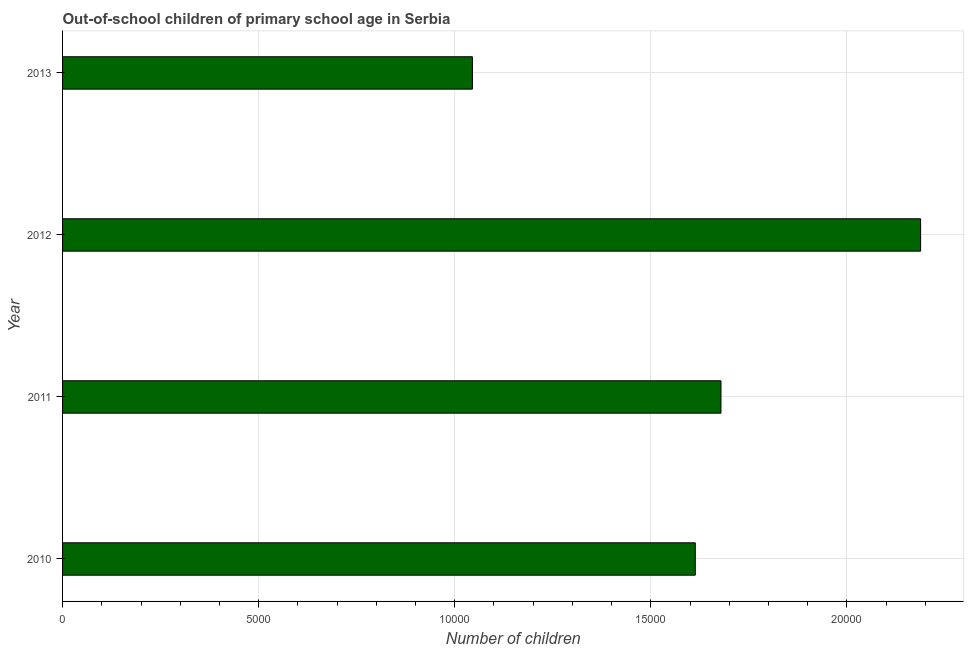What is the title of the graph?
Provide a short and direct response. Out-of-school children of primary school age in Serbia. What is the label or title of the X-axis?
Provide a short and direct response. Number of children. What is the number of out-of-school children in 2012?
Keep it short and to the point. 2.19e+04. Across all years, what is the maximum number of out-of-school children?
Provide a succinct answer. 2.19e+04. Across all years, what is the minimum number of out-of-school children?
Your answer should be compact. 1.04e+04. In which year was the number of out-of-school children maximum?
Your answer should be compact. 2012. What is the sum of the number of out-of-school children?
Provide a short and direct response. 6.52e+04. What is the difference between the number of out-of-school children in 2010 and 2013?
Offer a very short reply. 5683. What is the average number of out-of-school children per year?
Provide a succinct answer. 1.63e+04. What is the median number of out-of-school children?
Provide a succinct answer. 1.65e+04. What is the ratio of the number of out-of-school children in 2010 to that in 2012?
Make the answer very short. 0.74. Is the difference between the number of out-of-school children in 2012 and 2013 greater than the difference between any two years?
Ensure brevity in your answer.  Yes. What is the difference between the highest and the second highest number of out-of-school children?
Make the answer very short. 5090. Is the sum of the number of out-of-school children in 2010 and 2011 greater than the maximum number of out-of-school children across all years?
Your response must be concise. Yes. What is the difference between the highest and the lowest number of out-of-school children?
Ensure brevity in your answer.  1.14e+04. In how many years, is the number of out-of-school children greater than the average number of out-of-school children taken over all years?
Give a very brief answer. 2. Are all the bars in the graph horizontal?
Your answer should be very brief. Yes. What is the Number of children of 2010?
Offer a very short reply. 1.61e+04. What is the Number of children in 2011?
Offer a terse response. 1.68e+04. What is the Number of children of 2012?
Your answer should be very brief. 2.19e+04. What is the Number of children of 2013?
Your answer should be compact. 1.04e+04. What is the difference between the Number of children in 2010 and 2011?
Your answer should be compact. -655. What is the difference between the Number of children in 2010 and 2012?
Give a very brief answer. -5745. What is the difference between the Number of children in 2010 and 2013?
Give a very brief answer. 5683. What is the difference between the Number of children in 2011 and 2012?
Provide a short and direct response. -5090. What is the difference between the Number of children in 2011 and 2013?
Give a very brief answer. 6338. What is the difference between the Number of children in 2012 and 2013?
Offer a very short reply. 1.14e+04. What is the ratio of the Number of children in 2010 to that in 2012?
Offer a very short reply. 0.74. What is the ratio of the Number of children in 2010 to that in 2013?
Keep it short and to the point. 1.54. What is the ratio of the Number of children in 2011 to that in 2012?
Your answer should be very brief. 0.77. What is the ratio of the Number of children in 2011 to that in 2013?
Ensure brevity in your answer.  1.61. What is the ratio of the Number of children in 2012 to that in 2013?
Provide a succinct answer. 2.09. 